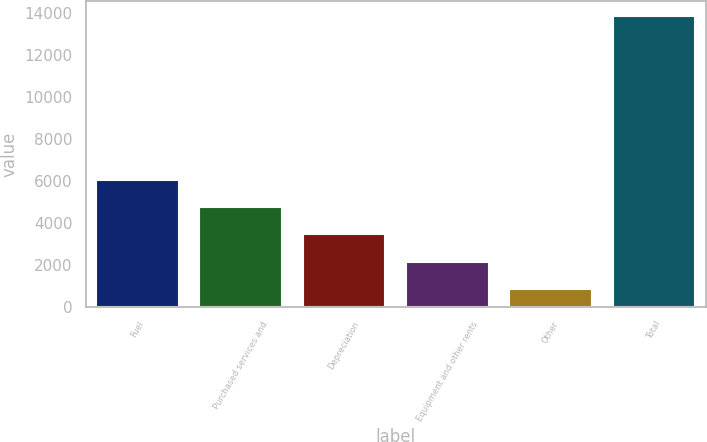Convert chart to OTSL. <chart><loc_0><loc_0><loc_500><loc_500><bar_chart><fcel>Fuel<fcel>Purchased services and<fcel>Depreciation<fcel>Equipment and other rents<fcel>Other<fcel>Total<nl><fcel>6062<fcel>4756.5<fcel>3451<fcel>2145.5<fcel>840<fcel>13895<nl></chart> 